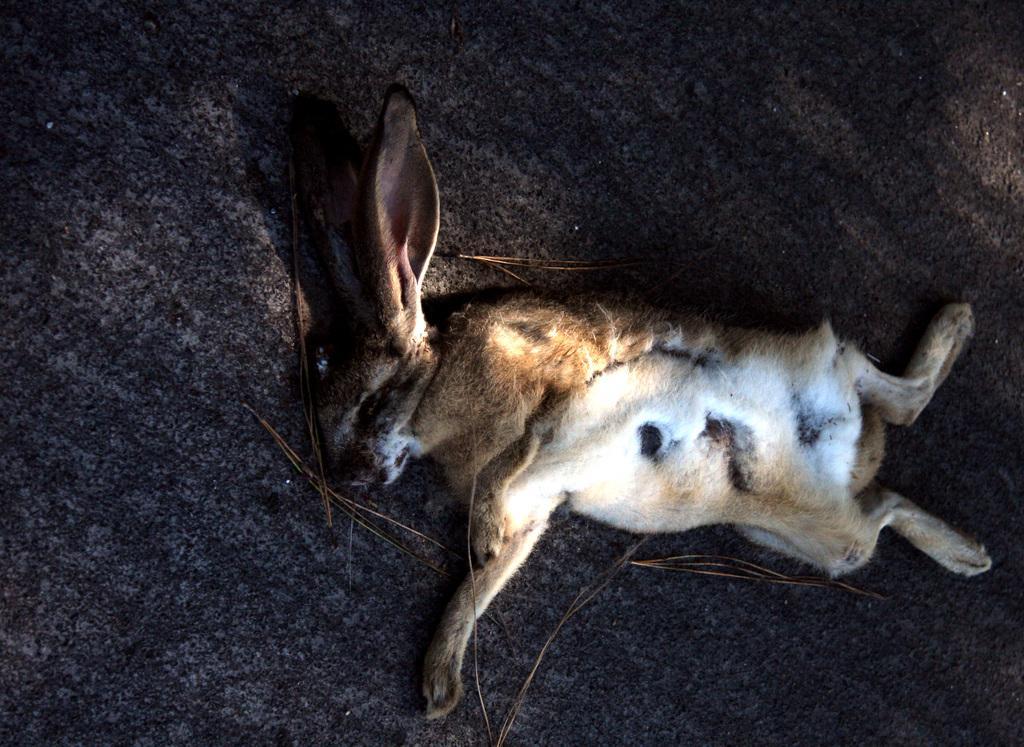Can you describe this image briefly? In the center of the image there is a animal laying on the ground. 